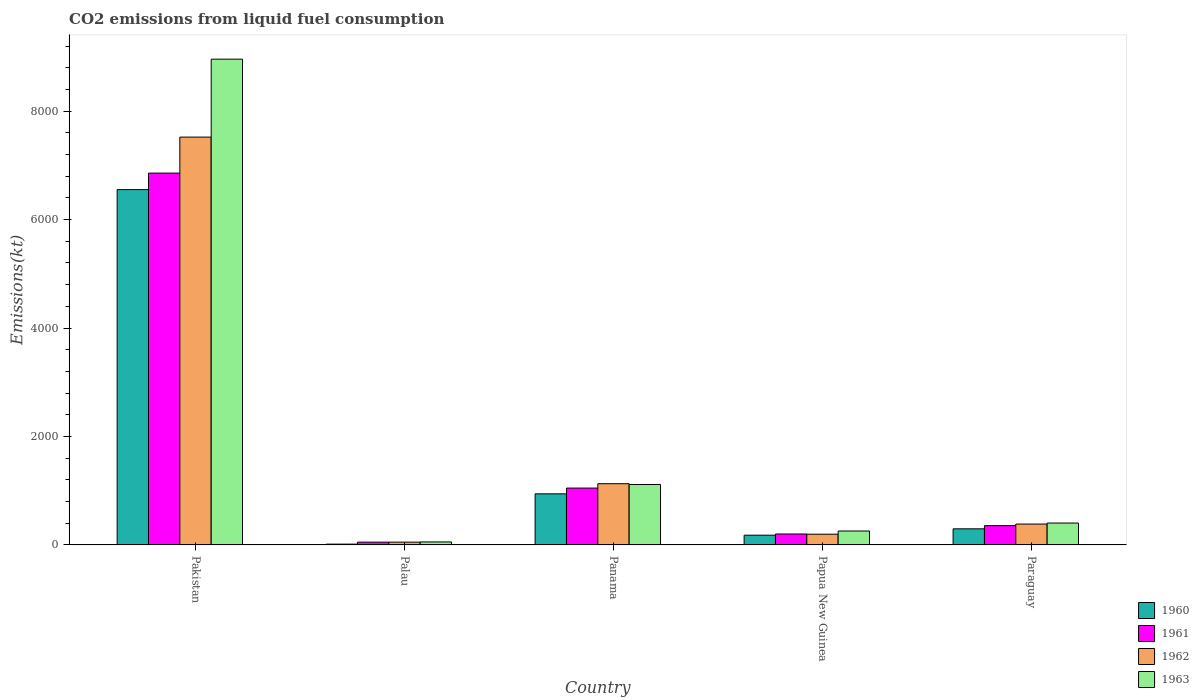How many different coloured bars are there?
Give a very brief answer. 4. How many groups of bars are there?
Provide a succinct answer. 5. What is the label of the 4th group of bars from the left?
Keep it short and to the point. Papua New Guinea. In how many cases, is the number of bars for a given country not equal to the number of legend labels?
Provide a succinct answer. 0. What is the amount of CO2 emitted in 1960 in Pakistan?
Your response must be concise. 6552.93. Across all countries, what is the maximum amount of CO2 emitted in 1961?
Make the answer very short. 6857.29. Across all countries, what is the minimum amount of CO2 emitted in 1962?
Ensure brevity in your answer.  51.34. In which country was the amount of CO2 emitted in 1960 minimum?
Keep it short and to the point. Palau. What is the total amount of CO2 emitted in 1963 in the graph?
Provide a succinct answer. 1.08e+04. What is the difference between the amount of CO2 emitted in 1963 in Panama and that in Paraguay?
Your response must be concise. 711.4. What is the difference between the amount of CO2 emitted in 1961 in Paraguay and the amount of CO2 emitted in 1960 in Papua New Guinea?
Your response must be concise. 176.02. What is the average amount of CO2 emitted in 1962 per country?
Provide a short and direct response. 1856.97. What is the difference between the amount of CO2 emitted of/in 1961 and amount of CO2 emitted of/in 1962 in Papua New Guinea?
Provide a short and direct response. 3.67. In how many countries, is the amount of CO2 emitted in 1961 greater than 1600 kt?
Ensure brevity in your answer.  1. What is the ratio of the amount of CO2 emitted in 1962 in Panama to that in Paraguay?
Offer a very short reply. 2.93. Is the amount of CO2 emitted in 1963 in Pakistan less than that in Panama?
Make the answer very short. No. What is the difference between the highest and the second highest amount of CO2 emitted in 1963?
Provide a succinct answer. 711.4. What is the difference between the highest and the lowest amount of CO2 emitted in 1960?
Ensure brevity in your answer.  6538.26. What does the 2nd bar from the right in Palau represents?
Your answer should be very brief. 1962. How many countries are there in the graph?
Ensure brevity in your answer.  5. What is the difference between two consecutive major ticks on the Y-axis?
Offer a very short reply. 2000. Are the values on the major ticks of Y-axis written in scientific E-notation?
Offer a terse response. No. Where does the legend appear in the graph?
Your answer should be very brief. Bottom right. How many legend labels are there?
Make the answer very short. 4. What is the title of the graph?
Provide a succinct answer. CO2 emissions from liquid fuel consumption. What is the label or title of the Y-axis?
Provide a short and direct response. Emissions(kt). What is the Emissions(kt) of 1960 in Pakistan?
Ensure brevity in your answer.  6552.93. What is the Emissions(kt) of 1961 in Pakistan?
Your answer should be very brief. 6857.29. What is the Emissions(kt) in 1962 in Pakistan?
Make the answer very short. 7521.02. What is the Emissions(kt) in 1963 in Pakistan?
Your answer should be compact. 8958.48. What is the Emissions(kt) in 1960 in Palau?
Offer a very short reply. 14.67. What is the Emissions(kt) of 1961 in Palau?
Your answer should be compact. 51.34. What is the Emissions(kt) in 1962 in Palau?
Keep it short and to the point. 51.34. What is the Emissions(kt) in 1963 in Palau?
Provide a short and direct response. 55.01. What is the Emissions(kt) in 1960 in Panama?
Your answer should be compact. 942.42. What is the Emissions(kt) in 1961 in Panama?
Your response must be concise. 1048.76. What is the Emissions(kt) in 1962 in Panama?
Provide a short and direct response. 1129.44. What is the Emissions(kt) of 1963 in Panama?
Your answer should be compact. 1114.77. What is the Emissions(kt) in 1960 in Papua New Guinea?
Give a very brief answer. 179.68. What is the Emissions(kt) of 1961 in Papua New Guinea?
Make the answer very short. 201.69. What is the Emissions(kt) in 1962 in Papua New Guinea?
Offer a very short reply. 198.02. What is the Emissions(kt) of 1963 in Papua New Guinea?
Your answer should be very brief. 256.69. What is the Emissions(kt) of 1960 in Paraguay?
Ensure brevity in your answer.  297.03. What is the Emissions(kt) in 1961 in Paraguay?
Provide a short and direct response. 355.7. What is the Emissions(kt) in 1962 in Paraguay?
Your answer should be compact. 385.04. What is the Emissions(kt) in 1963 in Paraguay?
Your answer should be compact. 403.37. Across all countries, what is the maximum Emissions(kt) in 1960?
Ensure brevity in your answer.  6552.93. Across all countries, what is the maximum Emissions(kt) of 1961?
Make the answer very short. 6857.29. Across all countries, what is the maximum Emissions(kt) in 1962?
Offer a very short reply. 7521.02. Across all countries, what is the maximum Emissions(kt) of 1963?
Your answer should be compact. 8958.48. Across all countries, what is the minimum Emissions(kt) of 1960?
Keep it short and to the point. 14.67. Across all countries, what is the minimum Emissions(kt) in 1961?
Ensure brevity in your answer.  51.34. Across all countries, what is the minimum Emissions(kt) in 1962?
Provide a short and direct response. 51.34. Across all countries, what is the minimum Emissions(kt) of 1963?
Offer a terse response. 55.01. What is the total Emissions(kt) of 1960 in the graph?
Provide a succinct answer. 7986.73. What is the total Emissions(kt) in 1961 in the graph?
Provide a succinct answer. 8514.77. What is the total Emissions(kt) in 1962 in the graph?
Give a very brief answer. 9284.84. What is the total Emissions(kt) of 1963 in the graph?
Give a very brief answer. 1.08e+04. What is the difference between the Emissions(kt) of 1960 in Pakistan and that in Palau?
Your answer should be very brief. 6538.26. What is the difference between the Emissions(kt) of 1961 in Pakistan and that in Palau?
Your answer should be very brief. 6805.95. What is the difference between the Emissions(kt) of 1962 in Pakistan and that in Palau?
Offer a terse response. 7469.68. What is the difference between the Emissions(kt) in 1963 in Pakistan and that in Palau?
Ensure brevity in your answer.  8903.48. What is the difference between the Emissions(kt) of 1960 in Pakistan and that in Panama?
Your answer should be compact. 5610.51. What is the difference between the Emissions(kt) in 1961 in Pakistan and that in Panama?
Your answer should be compact. 5808.53. What is the difference between the Emissions(kt) in 1962 in Pakistan and that in Panama?
Provide a succinct answer. 6391.58. What is the difference between the Emissions(kt) in 1963 in Pakistan and that in Panama?
Give a very brief answer. 7843.71. What is the difference between the Emissions(kt) of 1960 in Pakistan and that in Papua New Guinea?
Your response must be concise. 6373.25. What is the difference between the Emissions(kt) in 1961 in Pakistan and that in Papua New Guinea?
Your response must be concise. 6655.6. What is the difference between the Emissions(kt) of 1962 in Pakistan and that in Papua New Guinea?
Ensure brevity in your answer.  7323. What is the difference between the Emissions(kt) in 1963 in Pakistan and that in Papua New Guinea?
Make the answer very short. 8701.79. What is the difference between the Emissions(kt) in 1960 in Pakistan and that in Paraguay?
Offer a terse response. 6255.9. What is the difference between the Emissions(kt) of 1961 in Pakistan and that in Paraguay?
Offer a terse response. 6501.59. What is the difference between the Emissions(kt) of 1962 in Pakistan and that in Paraguay?
Ensure brevity in your answer.  7135.98. What is the difference between the Emissions(kt) of 1963 in Pakistan and that in Paraguay?
Give a very brief answer. 8555.11. What is the difference between the Emissions(kt) of 1960 in Palau and that in Panama?
Your answer should be very brief. -927.75. What is the difference between the Emissions(kt) in 1961 in Palau and that in Panama?
Keep it short and to the point. -997.42. What is the difference between the Emissions(kt) in 1962 in Palau and that in Panama?
Keep it short and to the point. -1078.1. What is the difference between the Emissions(kt) of 1963 in Palau and that in Panama?
Your answer should be very brief. -1059.76. What is the difference between the Emissions(kt) in 1960 in Palau and that in Papua New Guinea?
Provide a short and direct response. -165.01. What is the difference between the Emissions(kt) of 1961 in Palau and that in Papua New Guinea?
Give a very brief answer. -150.35. What is the difference between the Emissions(kt) of 1962 in Palau and that in Papua New Guinea?
Make the answer very short. -146.68. What is the difference between the Emissions(kt) of 1963 in Palau and that in Papua New Guinea?
Your response must be concise. -201.69. What is the difference between the Emissions(kt) in 1960 in Palau and that in Paraguay?
Your answer should be very brief. -282.36. What is the difference between the Emissions(kt) of 1961 in Palau and that in Paraguay?
Ensure brevity in your answer.  -304.36. What is the difference between the Emissions(kt) in 1962 in Palau and that in Paraguay?
Offer a terse response. -333.7. What is the difference between the Emissions(kt) of 1963 in Palau and that in Paraguay?
Make the answer very short. -348.37. What is the difference between the Emissions(kt) in 1960 in Panama and that in Papua New Guinea?
Your answer should be very brief. 762.74. What is the difference between the Emissions(kt) of 1961 in Panama and that in Papua New Guinea?
Give a very brief answer. 847.08. What is the difference between the Emissions(kt) of 1962 in Panama and that in Papua New Guinea?
Your response must be concise. 931.42. What is the difference between the Emissions(kt) of 1963 in Panama and that in Papua New Guinea?
Offer a very short reply. 858.08. What is the difference between the Emissions(kt) in 1960 in Panama and that in Paraguay?
Make the answer very short. 645.39. What is the difference between the Emissions(kt) of 1961 in Panama and that in Paraguay?
Make the answer very short. 693.06. What is the difference between the Emissions(kt) of 1962 in Panama and that in Paraguay?
Offer a very short reply. 744.4. What is the difference between the Emissions(kt) of 1963 in Panama and that in Paraguay?
Offer a very short reply. 711.4. What is the difference between the Emissions(kt) of 1960 in Papua New Guinea and that in Paraguay?
Keep it short and to the point. -117.34. What is the difference between the Emissions(kt) in 1961 in Papua New Guinea and that in Paraguay?
Keep it short and to the point. -154.01. What is the difference between the Emissions(kt) of 1962 in Papua New Guinea and that in Paraguay?
Offer a very short reply. -187.02. What is the difference between the Emissions(kt) in 1963 in Papua New Guinea and that in Paraguay?
Ensure brevity in your answer.  -146.68. What is the difference between the Emissions(kt) of 1960 in Pakistan and the Emissions(kt) of 1961 in Palau?
Give a very brief answer. 6501.59. What is the difference between the Emissions(kt) of 1960 in Pakistan and the Emissions(kt) of 1962 in Palau?
Offer a very short reply. 6501.59. What is the difference between the Emissions(kt) in 1960 in Pakistan and the Emissions(kt) in 1963 in Palau?
Provide a short and direct response. 6497.92. What is the difference between the Emissions(kt) in 1961 in Pakistan and the Emissions(kt) in 1962 in Palau?
Keep it short and to the point. 6805.95. What is the difference between the Emissions(kt) of 1961 in Pakistan and the Emissions(kt) of 1963 in Palau?
Give a very brief answer. 6802.28. What is the difference between the Emissions(kt) of 1962 in Pakistan and the Emissions(kt) of 1963 in Palau?
Your answer should be very brief. 7466.01. What is the difference between the Emissions(kt) of 1960 in Pakistan and the Emissions(kt) of 1961 in Panama?
Give a very brief answer. 5504.17. What is the difference between the Emissions(kt) in 1960 in Pakistan and the Emissions(kt) in 1962 in Panama?
Give a very brief answer. 5423.49. What is the difference between the Emissions(kt) of 1960 in Pakistan and the Emissions(kt) of 1963 in Panama?
Make the answer very short. 5438.16. What is the difference between the Emissions(kt) in 1961 in Pakistan and the Emissions(kt) in 1962 in Panama?
Your answer should be very brief. 5727.85. What is the difference between the Emissions(kt) of 1961 in Pakistan and the Emissions(kt) of 1963 in Panama?
Provide a short and direct response. 5742.52. What is the difference between the Emissions(kt) in 1962 in Pakistan and the Emissions(kt) in 1963 in Panama?
Provide a short and direct response. 6406.25. What is the difference between the Emissions(kt) in 1960 in Pakistan and the Emissions(kt) in 1961 in Papua New Guinea?
Keep it short and to the point. 6351.24. What is the difference between the Emissions(kt) of 1960 in Pakistan and the Emissions(kt) of 1962 in Papua New Guinea?
Your answer should be compact. 6354.91. What is the difference between the Emissions(kt) of 1960 in Pakistan and the Emissions(kt) of 1963 in Papua New Guinea?
Your answer should be very brief. 6296.24. What is the difference between the Emissions(kt) in 1961 in Pakistan and the Emissions(kt) in 1962 in Papua New Guinea?
Give a very brief answer. 6659.27. What is the difference between the Emissions(kt) in 1961 in Pakistan and the Emissions(kt) in 1963 in Papua New Guinea?
Ensure brevity in your answer.  6600.6. What is the difference between the Emissions(kt) of 1962 in Pakistan and the Emissions(kt) of 1963 in Papua New Guinea?
Give a very brief answer. 7264.33. What is the difference between the Emissions(kt) of 1960 in Pakistan and the Emissions(kt) of 1961 in Paraguay?
Provide a succinct answer. 6197.23. What is the difference between the Emissions(kt) of 1960 in Pakistan and the Emissions(kt) of 1962 in Paraguay?
Ensure brevity in your answer.  6167.89. What is the difference between the Emissions(kt) in 1960 in Pakistan and the Emissions(kt) in 1963 in Paraguay?
Provide a short and direct response. 6149.56. What is the difference between the Emissions(kt) in 1961 in Pakistan and the Emissions(kt) in 1962 in Paraguay?
Ensure brevity in your answer.  6472.26. What is the difference between the Emissions(kt) in 1961 in Pakistan and the Emissions(kt) in 1963 in Paraguay?
Ensure brevity in your answer.  6453.92. What is the difference between the Emissions(kt) of 1962 in Pakistan and the Emissions(kt) of 1963 in Paraguay?
Your answer should be very brief. 7117.65. What is the difference between the Emissions(kt) in 1960 in Palau and the Emissions(kt) in 1961 in Panama?
Keep it short and to the point. -1034.09. What is the difference between the Emissions(kt) in 1960 in Palau and the Emissions(kt) in 1962 in Panama?
Your answer should be very brief. -1114.77. What is the difference between the Emissions(kt) in 1960 in Palau and the Emissions(kt) in 1963 in Panama?
Give a very brief answer. -1100.1. What is the difference between the Emissions(kt) of 1961 in Palau and the Emissions(kt) of 1962 in Panama?
Your answer should be very brief. -1078.1. What is the difference between the Emissions(kt) in 1961 in Palau and the Emissions(kt) in 1963 in Panama?
Provide a succinct answer. -1063.43. What is the difference between the Emissions(kt) in 1962 in Palau and the Emissions(kt) in 1963 in Panama?
Provide a short and direct response. -1063.43. What is the difference between the Emissions(kt) of 1960 in Palau and the Emissions(kt) of 1961 in Papua New Guinea?
Your answer should be compact. -187.02. What is the difference between the Emissions(kt) of 1960 in Palau and the Emissions(kt) of 1962 in Papua New Guinea?
Your answer should be compact. -183.35. What is the difference between the Emissions(kt) of 1960 in Palau and the Emissions(kt) of 1963 in Papua New Guinea?
Your response must be concise. -242.02. What is the difference between the Emissions(kt) of 1961 in Palau and the Emissions(kt) of 1962 in Papua New Guinea?
Provide a succinct answer. -146.68. What is the difference between the Emissions(kt) in 1961 in Palau and the Emissions(kt) in 1963 in Papua New Guinea?
Offer a terse response. -205.35. What is the difference between the Emissions(kt) of 1962 in Palau and the Emissions(kt) of 1963 in Papua New Guinea?
Offer a terse response. -205.35. What is the difference between the Emissions(kt) of 1960 in Palau and the Emissions(kt) of 1961 in Paraguay?
Your response must be concise. -341.03. What is the difference between the Emissions(kt) in 1960 in Palau and the Emissions(kt) in 1962 in Paraguay?
Provide a succinct answer. -370.37. What is the difference between the Emissions(kt) of 1960 in Palau and the Emissions(kt) of 1963 in Paraguay?
Offer a terse response. -388.7. What is the difference between the Emissions(kt) of 1961 in Palau and the Emissions(kt) of 1962 in Paraguay?
Make the answer very short. -333.7. What is the difference between the Emissions(kt) of 1961 in Palau and the Emissions(kt) of 1963 in Paraguay?
Your response must be concise. -352.03. What is the difference between the Emissions(kt) of 1962 in Palau and the Emissions(kt) of 1963 in Paraguay?
Offer a terse response. -352.03. What is the difference between the Emissions(kt) in 1960 in Panama and the Emissions(kt) in 1961 in Papua New Guinea?
Your answer should be compact. 740.73. What is the difference between the Emissions(kt) of 1960 in Panama and the Emissions(kt) of 1962 in Papua New Guinea?
Provide a succinct answer. 744.4. What is the difference between the Emissions(kt) of 1960 in Panama and the Emissions(kt) of 1963 in Papua New Guinea?
Give a very brief answer. 685.73. What is the difference between the Emissions(kt) of 1961 in Panama and the Emissions(kt) of 1962 in Papua New Guinea?
Provide a succinct answer. 850.74. What is the difference between the Emissions(kt) in 1961 in Panama and the Emissions(kt) in 1963 in Papua New Guinea?
Provide a short and direct response. 792.07. What is the difference between the Emissions(kt) in 1962 in Panama and the Emissions(kt) in 1963 in Papua New Guinea?
Offer a very short reply. 872.75. What is the difference between the Emissions(kt) of 1960 in Panama and the Emissions(kt) of 1961 in Paraguay?
Your answer should be very brief. 586.72. What is the difference between the Emissions(kt) in 1960 in Panama and the Emissions(kt) in 1962 in Paraguay?
Ensure brevity in your answer.  557.38. What is the difference between the Emissions(kt) of 1960 in Panama and the Emissions(kt) of 1963 in Paraguay?
Give a very brief answer. 539.05. What is the difference between the Emissions(kt) in 1961 in Panama and the Emissions(kt) in 1962 in Paraguay?
Give a very brief answer. 663.73. What is the difference between the Emissions(kt) in 1961 in Panama and the Emissions(kt) in 1963 in Paraguay?
Provide a short and direct response. 645.39. What is the difference between the Emissions(kt) in 1962 in Panama and the Emissions(kt) in 1963 in Paraguay?
Your response must be concise. 726.07. What is the difference between the Emissions(kt) in 1960 in Papua New Guinea and the Emissions(kt) in 1961 in Paraguay?
Provide a short and direct response. -176.02. What is the difference between the Emissions(kt) in 1960 in Papua New Guinea and the Emissions(kt) in 1962 in Paraguay?
Give a very brief answer. -205.35. What is the difference between the Emissions(kt) in 1960 in Papua New Guinea and the Emissions(kt) in 1963 in Paraguay?
Provide a short and direct response. -223.69. What is the difference between the Emissions(kt) of 1961 in Papua New Guinea and the Emissions(kt) of 1962 in Paraguay?
Your answer should be compact. -183.35. What is the difference between the Emissions(kt) in 1961 in Papua New Guinea and the Emissions(kt) in 1963 in Paraguay?
Keep it short and to the point. -201.69. What is the difference between the Emissions(kt) in 1962 in Papua New Guinea and the Emissions(kt) in 1963 in Paraguay?
Your response must be concise. -205.35. What is the average Emissions(kt) in 1960 per country?
Ensure brevity in your answer.  1597.35. What is the average Emissions(kt) of 1961 per country?
Offer a terse response. 1702.95. What is the average Emissions(kt) of 1962 per country?
Give a very brief answer. 1856.97. What is the average Emissions(kt) of 1963 per country?
Make the answer very short. 2157.66. What is the difference between the Emissions(kt) of 1960 and Emissions(kt) of 1961 in Pakistan?
Your response must be concise. -304.36. What is the difference between the Emissions(kt) in 1960 and Emissions(kt) in 1962 in Pakistan?
Offer a terse response. -968.09. What is the difference between the Emissions(kt) of 1960 and Emissions(kt) of 1963 in Pakistan?
Make the answer very short. -2405.55. What is the difference between the Emissions(kt) in 1961 and Emissions(kt) in 1962 in Pakistan?
Provide a succinct answer. -663.73. What is the difference between the Emissions(kt) of 1961 and Emissions(kt) of 1963 in Pakistan?
Provide a short and direct response. -2101.19. What is the difference between the Emissions(kt) in 1962 and Emissions(kt) in 1963 in Pakistan?
Provide a succinct answer. -1437.46. What is the difference between the Emissions(kt) of 1960 and Emissions(kt) of 1961 in Palau?
Your answer should be very brief. -36.67. What is the difference between the Emissions(kt) of 1960 and Emissions(kt) of 1962 in Palau?
Your answer should be very brief. -36.67. What is the difference between the Emissions(kt) of 1960 and Emissions(kt) of 1963 in Palau?
Provide a succinct answer. -40.34. What is the difference between the Emissions(kt) in 1961 and Emissions(kt) in 1963 in Palau?
Keep it short and to the point. -3.67. What is the difference between the Emissions(kt) in 1962 and Emissions(kt) in 1963 in Palau?
Make the answer very short. -3.67. What is the difference between the Emissions(kt) of 1960 and Emissions(kt) of 1961 in Panama?
Make the answer very short. -106.34. What is the difference between the Emissions(kt) of 1960 and Emissions(kt) of 1962 in Panama?
Ensure brevity in your answer.  -187.02. What is the difference between the Emissions(kt) of 1960 and Emissions(kt) of 1963 in Panama?
Ensure brevity in your answer.  -172.35. What is the difference between the Emissions(kt) in 1961 and Emissions(kt) in 1962 in Panama?
Offer a very short reply. -80.67. What is the difference between the Emissions(kt) of 1961 and Emissions(kt) of 1963 in Panama?
Your response must be concise. -66.01. What is the difference between the Emissions(kt) of 1962 and Emissions(kt) of 1963 in Panama?
Give a very brief answer. 14.67. What is the difference between the Emissions(kt) in 1960 and Emissions(kt) in 1961 in Papua New Guinea?
Your answer should be very brief. -22. What is the difference between the Emissions(kt) of 1960 and Emissions(kt) of 1962 in Papua New Guinea?
Provide a short and direct response. -18.34. What is the difference between the Emissions(kt) in 1960 and Emissions(kt) in 1963 in Papua New Guinea?
Give a very brief answer. -77.01. What is the difference between the Emissions(kt) of 1961 and Emissions(kt) of 1962 in Papua New Guinea?
Provide a succinct answer. 3.67. What is the difference between the Emissions(kt) of 1961 and Emissions(kt) of 1963 in Papua New Guinea?
Offer a terse response. -55.01. What is the difference between the Emissions(kt) in 1962 and Emissions(kt) in 1963 in Papua New Guinea?
Give a very brief answer. -58.67. What is the difference between the Emissions(kt) in 1960 and Emissions(kt) in 1961 in Paraguay?
Provide a succinct answer. -58.67. What is the difference between the Emissions(kt) of 1960 and Emissions(kt) of 1962 in Paraguay?
Your answer should be compact. -88.01. What is the difference between the Emissions(kt) of 1960 and Emissions(kt) of 1963 in Paraguay?
Offer a very short reply. -106.34. What is the difference between the Emissions(kt) of 1961 and Emissions(kt) of 1962 in Paraguay?
Make the answer very short. -29.34. What is the difference between the Emissions(kt) in 1961 and Emissions(kt) in 1963 in Paraguay?
Your answer should be very brief. -47.67. What is the difference between the Emissions(kt) in 1962 and Emissions(kt) in 1963 in Paraguay?
Ensure brevity in your answer.  -18.34. What is the ratio of the Emissions(kt) of 1960 in Pakistan to that in Palau?
Your response must be concise. 446.75. What is the ratio of the Emissions(kt) of 1961 in Pakistan to that in Palau?
Provide a succinct answer. 133.57. What is the ratio of the Emissions(kt) of 1962 in Pakistan to that in Palau?
Provide a short and direct response. 146.5. What is the ratio of the Emissions(kt) of 1963 in Pakistan to that in Palau?
Your answer should be very brief. 162.87. What is the ratio of the Emissions(kt) of 1960 in Pakistan to that in Panama?
Ensure brevity in your answer.  6.95. What is the ratio of the Emissions(kt) in 1961 in Pakistan to that in Panama?
Your answer should be compact. 6.54. What is the ratio of the Emissions(kt) in 1962 in Pakistan to that in Panama?
Make the answer very short. 6.66. What is the ratio of the Emissions(kt) of 1963 in Pakistan to that in Panama?
Provide a short and direct response. 8.04. What is the ratio of the Emissions(kt) in 1960 in Pakistan to that in Papua New Guinea?
Your response must be concise. 36.47. What is the ratio of the Emissions(kt) of 1962 in Pakistan to that in Papua New Guinea?
Offer a terse response. 37.98. What is the ratio of the Emissions(kt) in 1963 in Pakistan to that in Papua New Guinea?
Your answer should be very brief. 34.9. What is the ratio of the Emissions(kt) in 1960 in Pakistan to that in Paraguay?
Ensure brevity in your answer.  22.06. What is the ratio of the Emissions(kt) of 1961 in Pakistan to that in Paraguay?
Offer a very short reply. 19.28. What is the ratio of the Emissions(kt) in 1962 in Pakistan to that in Paraguay?
Provide a short and direct response. 19.53. What is the ratio of the Emissions(kt) in 1963 in Pakistan to that in Paraguay?
Your answer should be very brief. 22.21. What is the ratio of the Emissions(kt) in 1960 in Palau to that in Panama?
Offer a very short reply. 0.02. What is the ratio of the Emissions(kt) in 1961 in Palau to that in Panama?
Offer a very short reply. 0.05. What is the ratio of the Emissions(kt) of 1962 in Palau to that in Panama?
Offer a very short reply. 0.05. What is the ratio of the Emissions(kt) in 1963 in Palau to that in Panama?
Your response must be concise. 0.05. What is the ratio of the Emissions(kt) of 1960 in Palau to that in Papua New Guinea?
Your answer should be very brief. 0.08. What is the ratio of the Emissions(kt) in 1961 in Palau to that in Papua New Guinea?
Give a very brief answer. 0.25. What is the ratio of the Emissions(kt) in 1962 in Palau to that in Papua New Guinea?
Your response must be concise. 0.26. What is the ratio of the Emissions(kt) in 1963 in Palau to that in Papua New Guinea?
Your answer should be compact. 0.21. What is the ratio of the Emissions(kt) in 1960 in Palau to that in Paraguay?
Make the answer very short. 0.05. What is the ratio of the Emissions(kt) of 1961 in Palau to that in Paraguay?
Offer a very short reply. 0.14. What is the ratio of the Emissions(kt) in 1962 in Palau to that in Paraguay?
Keep it short and to the point. 0.13. What is the ratio of the Emissions(kt) in 1963 in Palau to that in Paraguay?
Keep it short and to the point. 0.14. What is the ratio of the Emissions(kt) of 1960 in Panama to that in Papua New Guinea?
Ensure brevity in your answer.  5.24. What is the ratio of the Emissions(kt) in 1962 in Panama to that in Papua New Guinea?
Provide a succinct answer. 5.7. What is the ratio of the Emissions(kt) of 1963 in Panama to that in Papua New Guinea?
Provide a short and direct response. 4.34. What is the ratio of the Emissions(kt) of 1960 in Panama to that in Paraguay?
Keep it short and to the point. 3.17. What is the ratio of the Emissions(kt) in 1961 in Panama to that in Paraguay?
Your answer should be very brief. 2.95. What is the ratio of the Emissions(kt) in 1962 in Panama to that in Paraguay?
Give a very brief answer. 2.93. What is the ratio of the Emissions(kt) of 1963 in Panama to that in Paraguay?
Your answer should be very brief. 2.76. What is the ratio of the Emissions(kt) in 1960 in Papua New Guinea to that in Paraguay?
Give a very brief answer. 0.6. What is the ratio of the Emissions(kt) of 1961 in Papua New Guinea to that in Paraguay?
Offer a very short reply. 0.57. What is the ratio of the Emissions(kt) in 1962 in Papua New Guinea to that in Paraguay?
Your answer should be compact. 0.51. What is the ratio of the Emissions(kt) of 1963 in Papua New Guinea to that in Paraguay?
Offer a very short reply. 0.64. What is the difference between the highest and the second highest Emissions(kt) of 1960?
Offer a very short reply. 5610.51. What is the difference between the highest and the second highest Emissions(kt) of 1961?
Your response must be concise. 5808.53. What is the difference between the highest and the second highest Emissions(kt) of 1962?
Ensure brevity in your answer.  6391.58. What is the difference between the highest and the second highest Emissions(kt) of 1963?
Offer a very short reply. 7843.71. What is the difference between the highest and the lowest Emissions(kt) in 1960?
Offer a very short reply. 6538.26. What is the difference between the highest and the lowest Emissions(kt) in 1961?
Keep it short and to the point. 6805.95. What is the difference between the highest and the lowest Emissions(kt) in 1962?
Offer a terse response. 7469.68. What is the difference between the highest and the lowest Emissions(kt) in 1963?
Ensure brevity in your answer.  8903.48. 